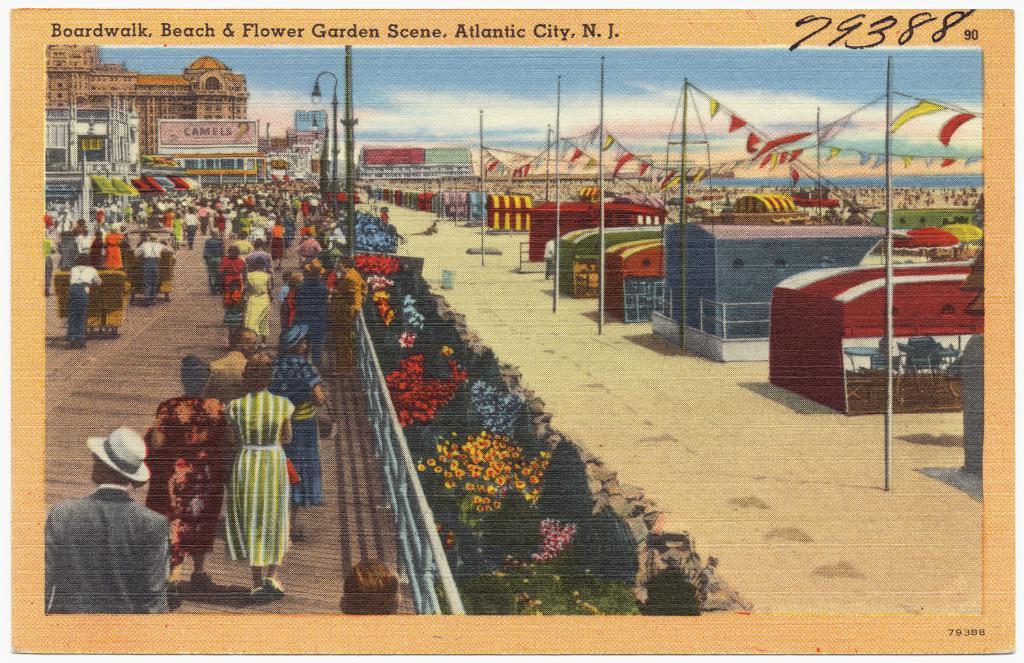Which state is this postcard featuring?
Ensure brevity in your answer.  New jersey. 